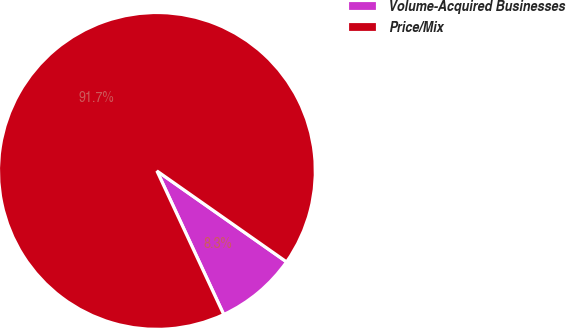<chart> <loc_0><loc_0><loc_500><loc_500><pie_chart><fcel>Volume-Acquired Businesses<fcel>Price/Mix<nl><fcel>8.33%<fcel>91.67%<nl></chart> 